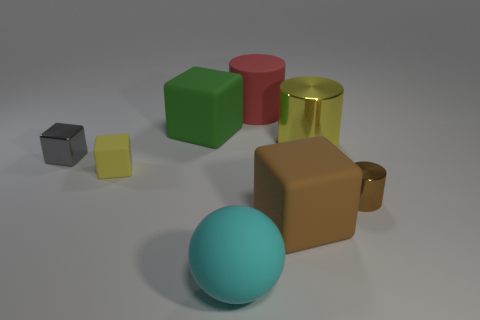Add 1 large red matte cylinders. How many objects exist? 9 Subtract all balls. How many objects are left? 7 Add 4 brown cylinders. How many brown cylinders exist? 5 Subtract 1 brown cylinders. How many objects are left? 7 Subtract all purple metallic things. Subtract all balls. How many objects are left? 7 Add 6 blocks. How many blocks are left? 10 